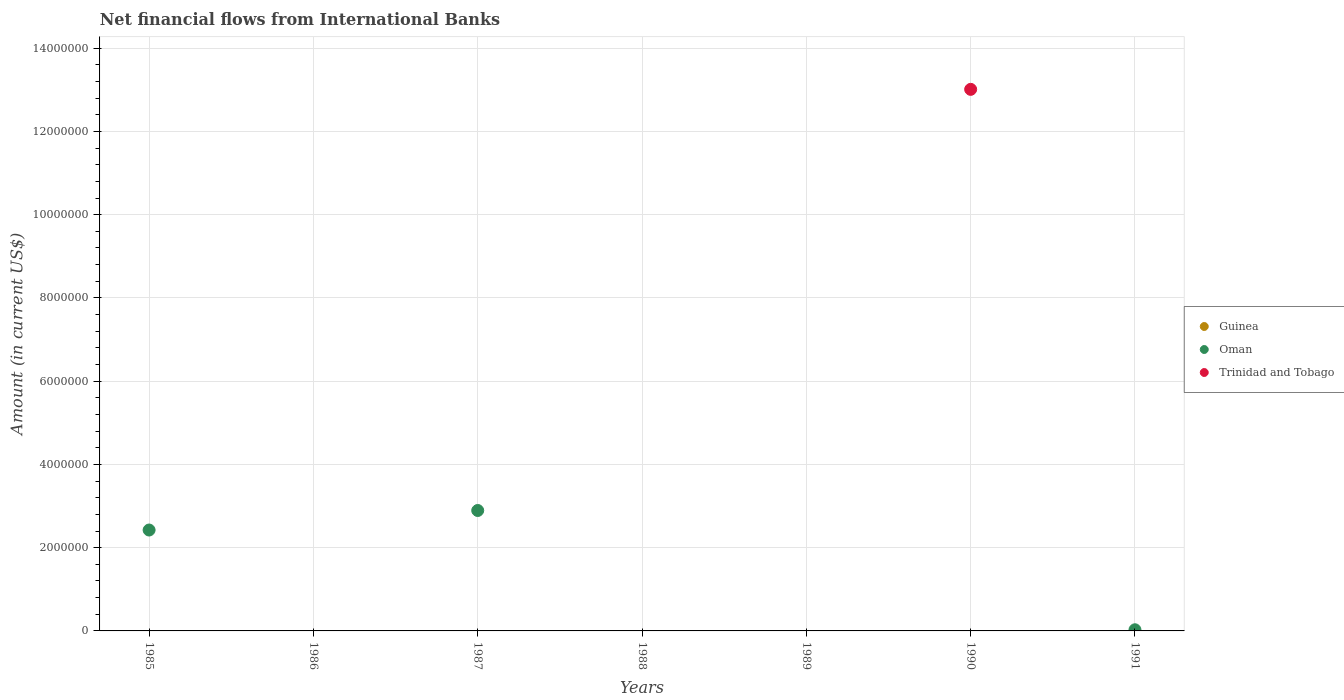Is the number of dotlines equal to the number of legend labels?
Provide a succinct answer. No. What is the net financial aid flows in Guinea in 1988?
Provide a short and direct response. 0. Across all years, what is the maximum net financial aid flows in Trinidad and Tobago?
Offer a terse response. 1.30e+07. What is the total net financial aid flows in Oman in the graph?
Give a very brief answer. 5.35e+06. What is the difference between the net financial aid flows in Oman in 1987 and that in 1991?
Your response must be concise. 2.87e+06. What is the average net financial aid flows in Oman per year?
Keep it short and to the point. 7.64e+05. What is the difference between the highest and the second highest net financial aid flows in Oman?
Offer a very short reply. 4.69e+05. What is the difference between the highest and the lowest net financial aid flows in Trinidad and Tobago?
Give a very brief answer. 1.30e+07. Is it the case that in every year, the sum of the net financial aid flows in Oman and net financial aid flows in Guinea  is greater than the net financial aid flows in Trinidad and Tobago?
Give a very brief answer. No. Does the net financial aid flows in Oman monotonically increase over the years?
Offer a very short reply. No. Is the net financial aid flows in Oman strictly less than the net financial aid flows in Trinidad and Tobago over the years?
Give a very brief answer. No. How many dotlines are there?
Offer a terse response. 2. How many years are there in the graph?
Offer a very short reply. 7. What is the difference between two consecutive major ticks on the Y-axis?
Offer a very short reply. 2.00e+06. Are the values on the major ticks of Y-axis written in scientific E-notation?
Make the answer very short. No. Where does the legend appear in the graph?
Make the answer very short. Center right. How many legend labels are there?
Your response must be concise. 3. How are the legend labels stacked?
Offer a terse response. Vertical. What is the title of the graph?
Provide a short and direct response. Net financial flows from International Banks. What is the label or title of the Y-axis?
Ensure brevity in your answer.  Amount (in current US$). What is the Amount (in current US$) of Guinea in 1985?
Give a very brief answer. 0. What is the Amount (in current US$) in Oman in 1985?
Your answer should be very brief. 2.42e+06. What is the Amount (in current US$) in Guinea in 1986?
Make the answer very short. 0. What is the Amount (in current US$) in Trinidad and Tobago in 1986?
Offer a terse response. 0. What is the Amount (in current US$) in Guinea in 1987?
Give a very brief answer. 0. What is the Amount (in current US$) in Oman in 1987?
Offer a very short reply. 2.89e+06. What is the Amount (in current US$) in Guinea in 1988?
Your answer should be very brief. 0. What is the Amount (in current US$) in Trinidad and Tobago in 1988?
Offer a very short reply. 0. What is the Amount (in current US$) of Oman in 1989?
Provide a short and direct response. 0. What is the Amount (in current US$) of Guinea in 1990?
Your answer should be very brief. 0. What is the Amount (in current US$) of Oman in 1990?
Offer a terse response. 0. What is the Amount (in current US$) of Trinidad and Tobago in 1990?
Provide a succinct answer. 1.30e+07. What is the Amount (in current US$) of Oman in 1991?
Provide a short and direct response. 2.78e+04. Across all years, what is the maximum Amount (in current US$) of Oman?
Make the answer very short. 2.89e+06. Across all years, what is the maximum Amount (in current US$) of Trinidad and Tobago?
Provide a short and direct response. 1.30e+07. Across all years, what is the minimum Amount (in current US$) in Oman?
Your answer should be compact. 0. What is the total Amount (in current US$) of Oman in the graph?
Keep it short and to the point. 5.35e+06. What is the total Amount (in current US$) in Trinidad and Tobago in the graph?
Provide a short and direct response. 1.30e+07. What is the difference between the Amount (in current US$) in Oman in 1985 and that in 1987?
Your response must be concise. -4.69e+05. What is the difference between the Amount (in current US$) of Oman in 1985 and that in 1991?
Your answer should be compact. 2.40e+06. What is the difference between the Amount (in current US$) of Oman in 1987 and that in 1991?
Provide a succinct answer. 2.87e+06. What is the difference between the Amount (in current US$) in Oman in 1985 and the Amount (in current US$) in Trinidad and Tobago in 1990?
Offer a terse response. -1.06e+07. What is the difference between the Amount (in current US$) in Oman in 1987 and the Amount (in current US$) in Trinidad and Tobago in 1990?
Keep it short and to the point. -1.01e+07. What is the average Amount (in current US$) in Oman per year?
Provide a short and direct response. 7.64e+05. What is the average Amount (in current US$) of Trinidad and Tobago per year?
Your answer should be very brief. 1.86e+06. What is the ratio of the Amount (in current US$) of Oman in 1985 to that in 1987?
Your answer should be very brief. 0.84. What is the ratio of the Amount (in current US$) of Oman in 1985 to that in 1991?
Offer a very short reply. 87.34. What is the ratio of the Amount (in current US$) in Oman in 1987 to that in 1991?
Offer a terse response. 104.25. What is the difference between the highest and the second highest Amount (in current US$) of Oman?
Keep it short and to the point. 4.69e+05. What is the difference between the highest and the lowest Amount (in current US$) of Oman?
Offer a very short reply. 2.89e+06. What is the difference between the highest and the lowest Amount (in current US$) of Trinidad and Tobago?
Your answer should be compact. 1.30e+07. 